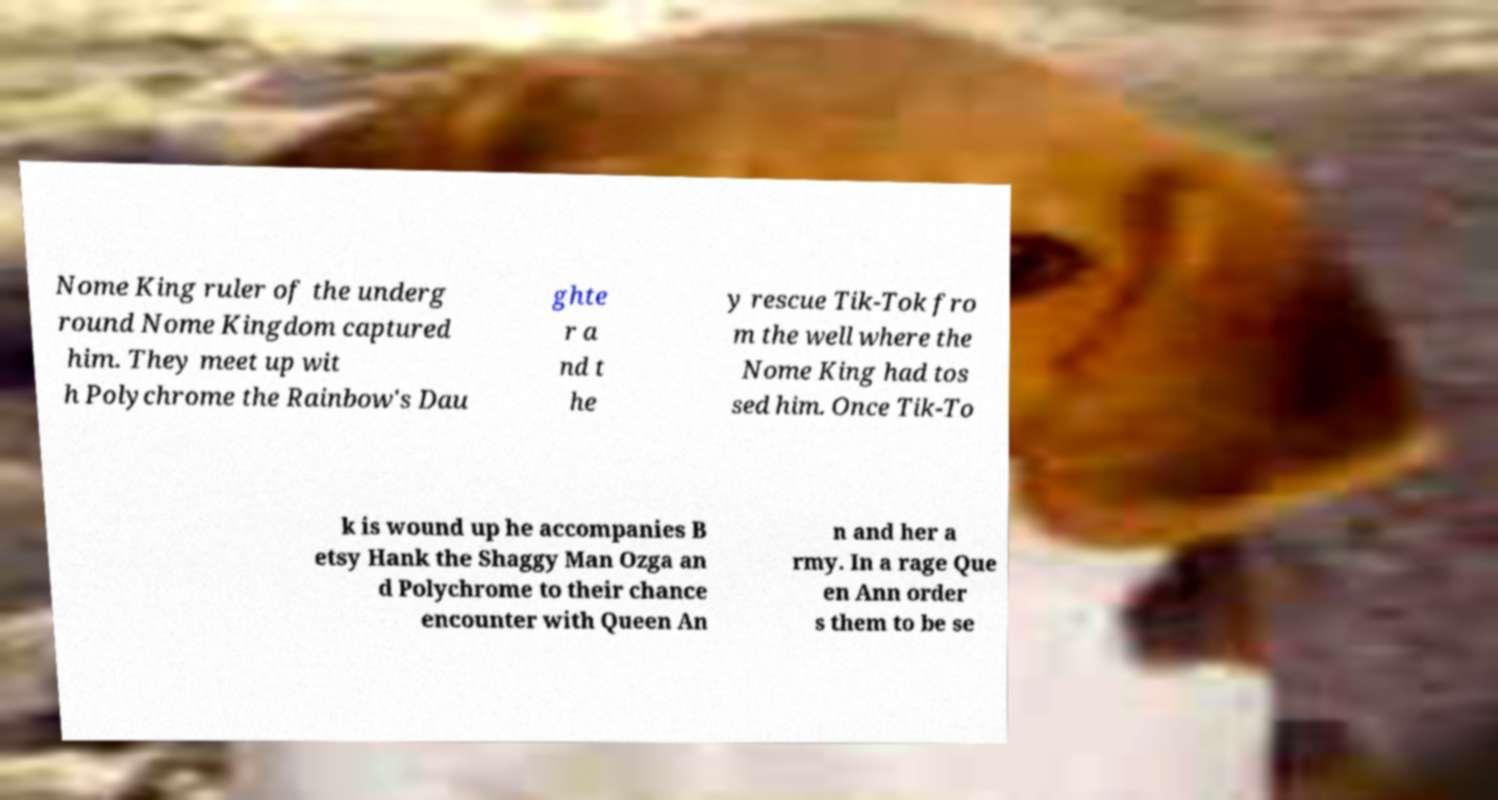Could you assist in decoding the text presented in this image and type it out clearly? Nome King ruler of the underg round Nome Kingdom captured him. They meet up wit h Polychrome the Rainbow's Dau ghte r a nd t he y rescue Tik-Tok fro m the well where the Nome King had tos sed him. Once Tik-To k is wound up he accompanies B etsy Hank the Shaggy Man Ozga an d Polychrome to their chance encounter with Queen An n and her a rmy. In a rage Que en Ann order s them to be se 